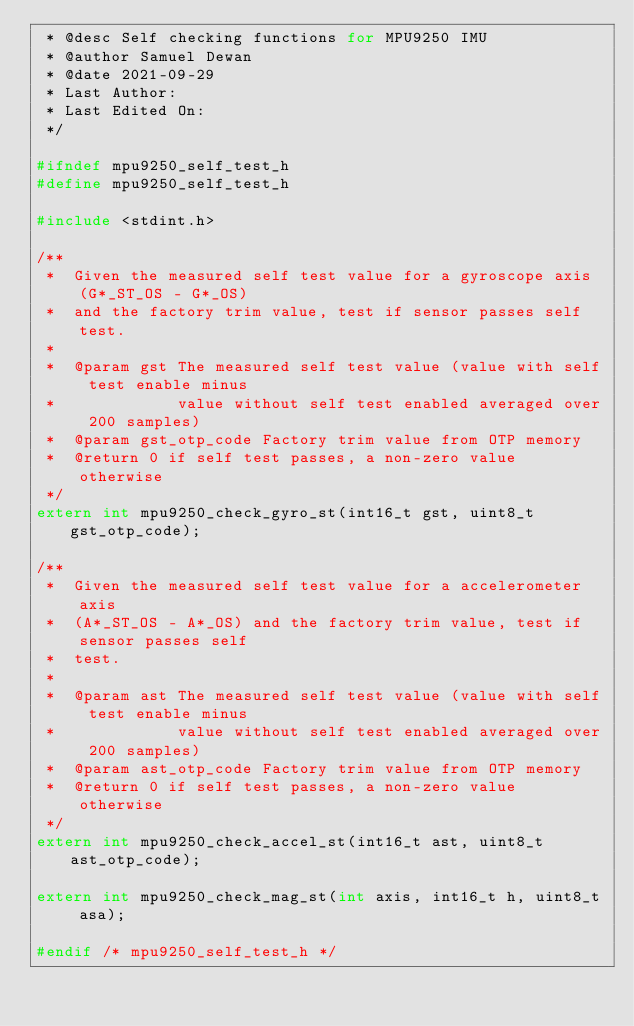Convert code to text. <code><loc_0><loc_0><loc_500><loc_500><_C_> * @desc Self checking functions for MPU9250 IMU
 * @author Samuel Dewan
 * @date 2021-09-29
 * Last Author:
 * Last Edited On:
 */

#ifndef mpu9250_self_test_h
#define mpu9250_self_test_h

#include <stdint.h>

/**
 *  Given the measured self test value for a gyroscope axis (G*_ST_OS - G*_OS)
 *  and the factory trim value, test if sensor passes self test.
 *
 *  @param gst The measured self test value (value with self test enable minus
 *             value without self test enabled averaged over 200 samples)
 *  @param gst_otp_code Factory trim value from OTP memory
 *  @return 0 if self test passes, a non-zero value otherwise
 */
extern int mpu9250_check_gyro_st(int16_t gst, uint8_t gst_otp_code);

/**
 *  Given the measured self test value for a accelerometer axis
 *  (A*_ST_OS - A*_OS) and the factory trim value, test if sensor passes self
 *  test.
 *
 *  @param ast The measured self test value (value with self test enable minus
 *             value without self test enabled averaged over 200 samples)
 *  @param ast_otp_code Factory trim value from OTP memory
 *  @return 0 if self test passes, a non-zero value otherwise
 */
extern int mpu9250_check_accel_st(int16_t ast, uint8_t ast_otp_code);

extern int mpu9250_check_mag_st(int axis, int16_t h, uint8_t asa);

#endif /* mpu9250_self_test_h */
</code> 